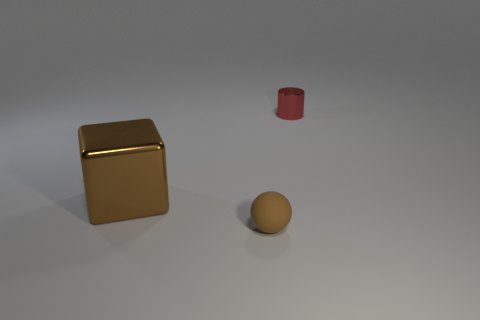There is a metal block that is the same color as the ball; what size is it?
Make the answer very short. Large. What number of other objects are the same color as the big metal object?
Offer a terse response. 1. There is a thing to the right of the tiny object that is in front of the tiny metal thing; what is its color?
Your answer should be compact. Red. Is the color of the sphere the same as the small thing behind the brown shiny thing?
Ensure brevity in your answer.  No. What is the thing that is both on the right side of the big brown metal object and in front of the tiny metal thing made of?
Make the answer very short. Rubber. Is there another brown matte thing that has the same size as the rubber thing?
Offer a terse response. No. There is a red thing that is the same size as the brown ball; what material is it?
Keep it short and to the point. Metal. What number of things are behind the tiny ball?
Your answer should be compact. 2. Do the metal object right of the cube and the small brown rubber thing have the same shape?
Give a very brief answer. No. Is there a rubber object of the same shape as the small metal thing?
Provide a short and direct response. No. 